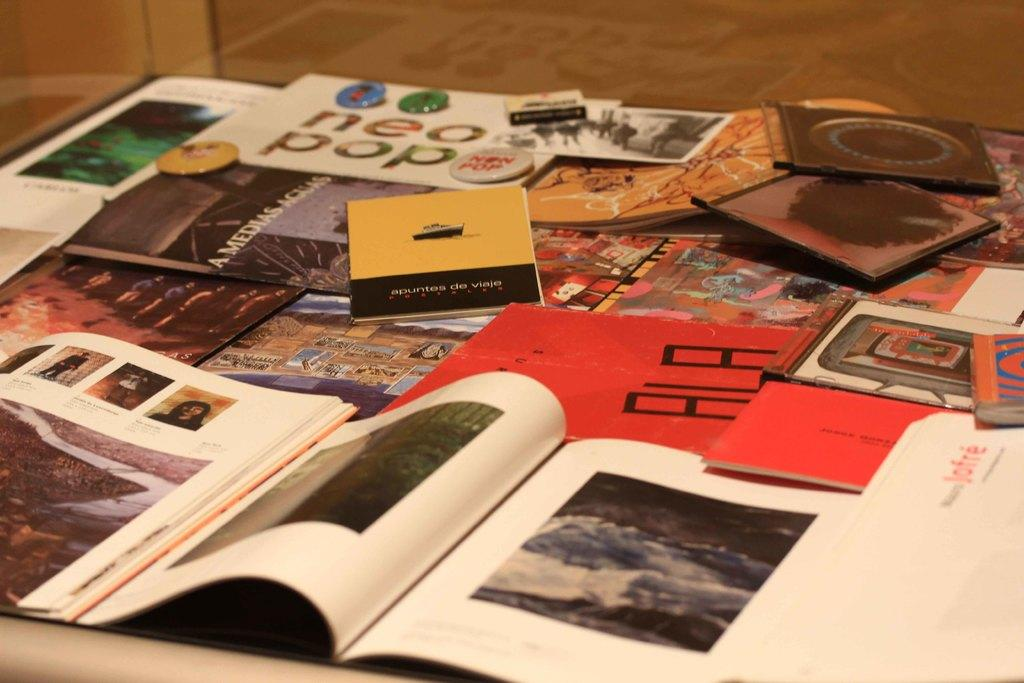<image>
Summarize the visual content of the image. An interesting array of various reading materials including magazines. 